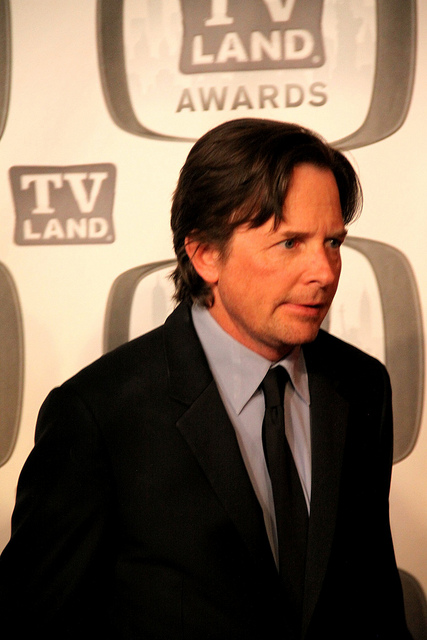<image>Who is this? I am not sure who this is. It can be the actor Michael J Fox. Who is this? I don't know who this is. But it can be Michael J Fox. 